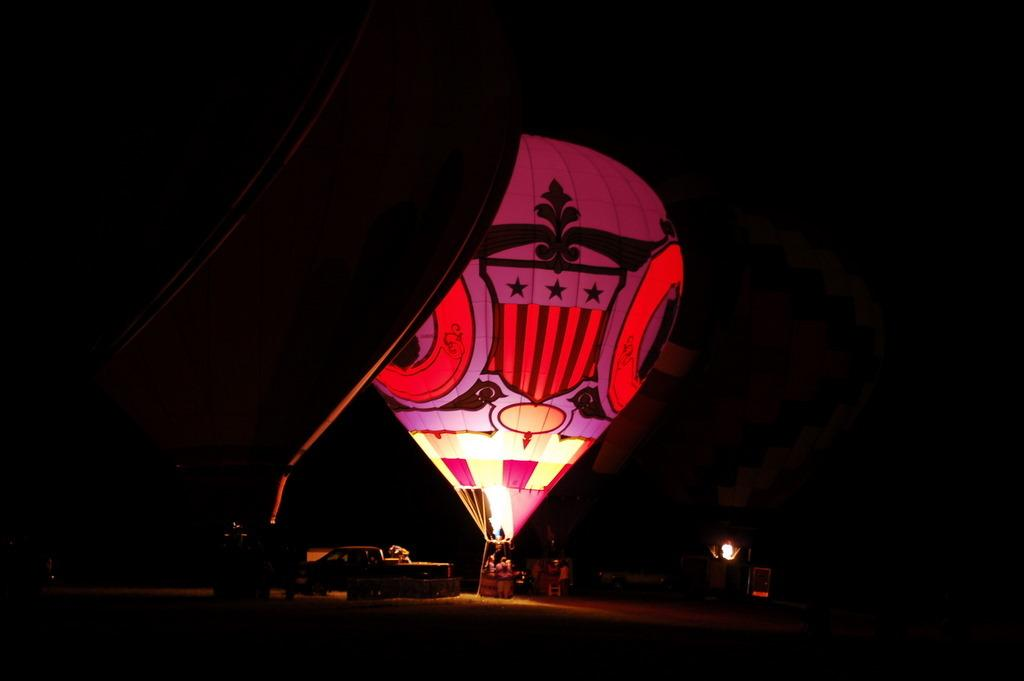What is the main subject of the image? The main subject of the image is a car. What other objects can be seen in the image? There are two air balloons in the image. Can you describe the light source in the image? There is a light source in the image, but its specific details are not mentioned. Who or what is present in the image? There are people in the image. How would you describe the background of the image? The background of the image is dark. What type of polish is being applied to the car in the image? There is no indication in the image that any polish is being applied to the car. Can you see a tin can in the image? There is no mention of a tin can in the image. 